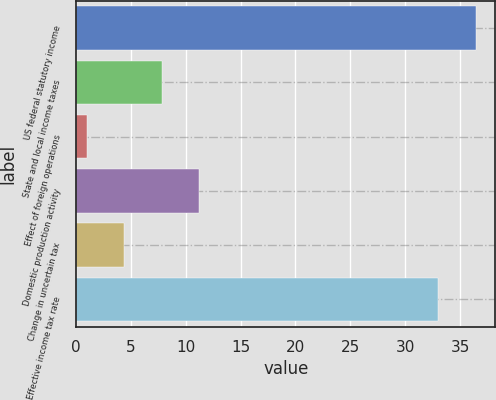Convert chart to OTSL. <chart><loc_0><loc_0><loc_500><loc_500><bar_chart><fcel>US federal statutory income<fcel>State and local income taxes<fcel>Effect of foreign operations<fcel>Domestic production activity<fcel>Change in uncertain tax<fcel>Effective income tax rate<nl><fcel>36.4<fcel>7.8<fcel>1<fcel>11.2<fcel>4.4<fcel>33<nl></chart> 